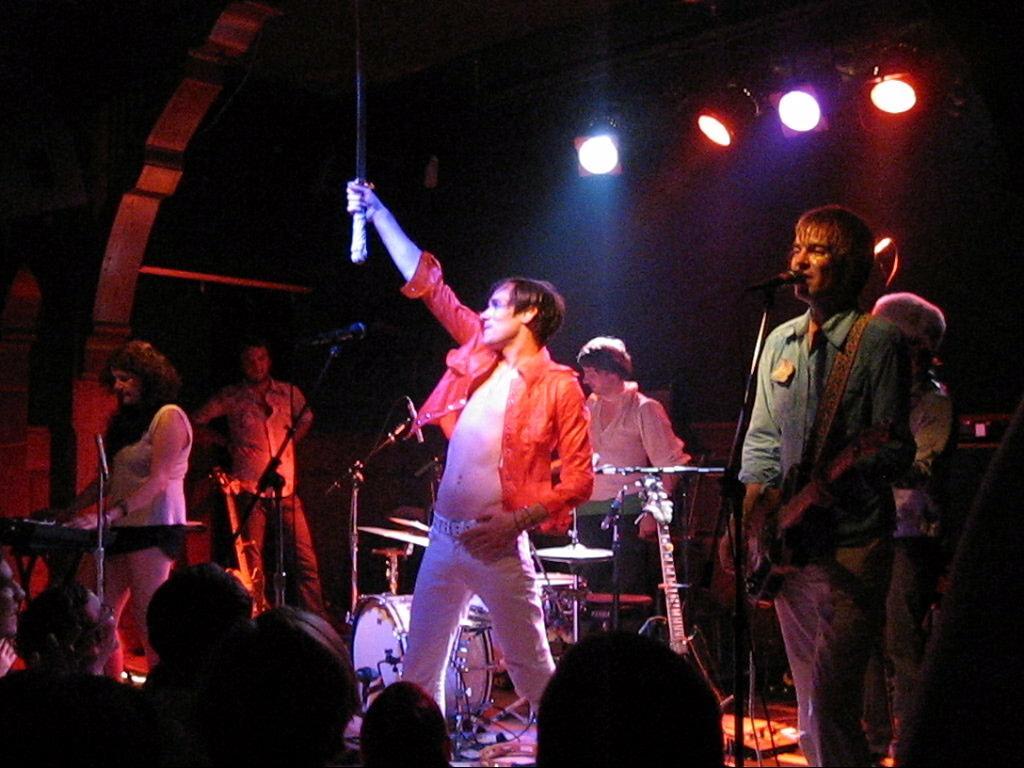Please provide a concise description of this image. In this image we can see many people standing. Some are playing musical instruments. There are mics with mic stands. There is a person holding a mic. At the bottom we can see many people. In the background it is dark. Also there are lights. 